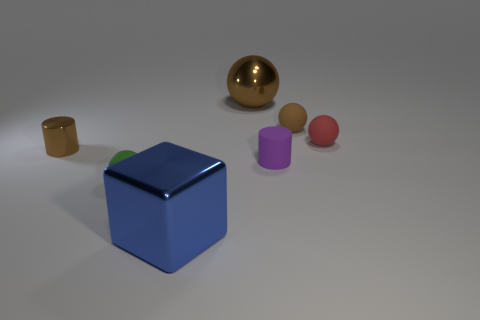There is a small cylinder that is the same color as the large sphere; what material is it?
Ensure brevity in your answer.  Metal. There is a metallic thing on the right side of the large blue cube; how big is it?
Your response must be concise. Large. What material is the ball that is the same size as the blue shiny block?
Keep it short and to the point. Metal. Are there more tiny blue shiny objects than small red spheres?
Provide a short and direct response. No. There is a cylinder right of the large brown metal thing that is behind the red rubber sphere; what is its size?
Your answer should be very brief. Small. What shape is the red thing that is the same size as the purple thing?
Provide a short and direct response. Sphere. There is a large thing that is behind the rubber ball that is in front of the small brown thing on the left side of the big blue metallic thing; what shape is it?
Ensure brevity in your answer.  Sphere. Does the tiny cylinder that is on the left side of the big ball have the same color as the large thing right of the large cube?
Your response must be concise. Yes. What number of blue blocks are there?
Provide a succinct answer. 1. There is a big blue object; are there any small green balls left of it?
Your answer should be very brief. Yes. 